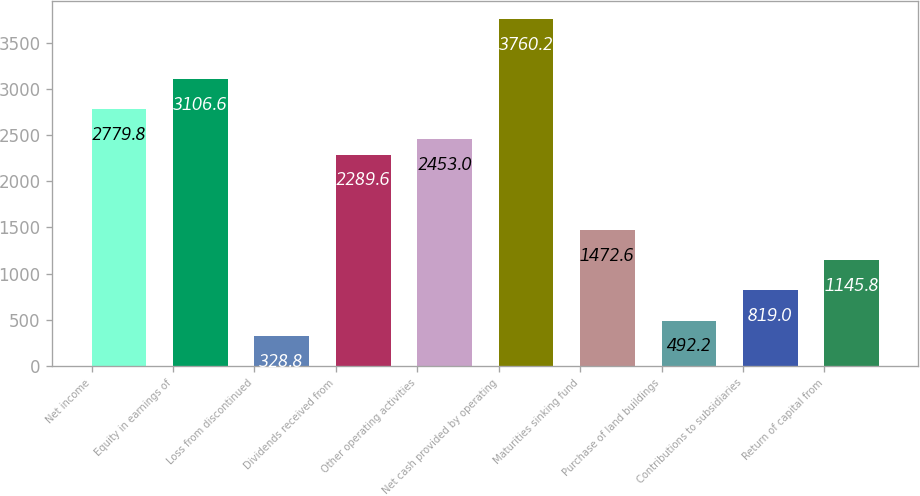Convert chart. <chart><loc_0><loc_0><loc_500><loc_500><bar_chart><fcel>Net income<fcel>Equity in earnings of<fcel>Loss from discontinued<fcel>Dividends received from<fcel>Other operating activities<fcel>Net cash provided by operating<fcel>Maturities sinking fund<fcel>Purchase of land buildings<fcel>Contributions to subsidiaries<fcel>Return of capital from<nl><fcel>2779.8<fcel>3106.6<fcel>328.8<fcel>2289.6<fcel>2453<fcel>3760.2<fcel>1472.6<fcel>492.2<fcel>819<fcel>1145.8<nl></chart> 